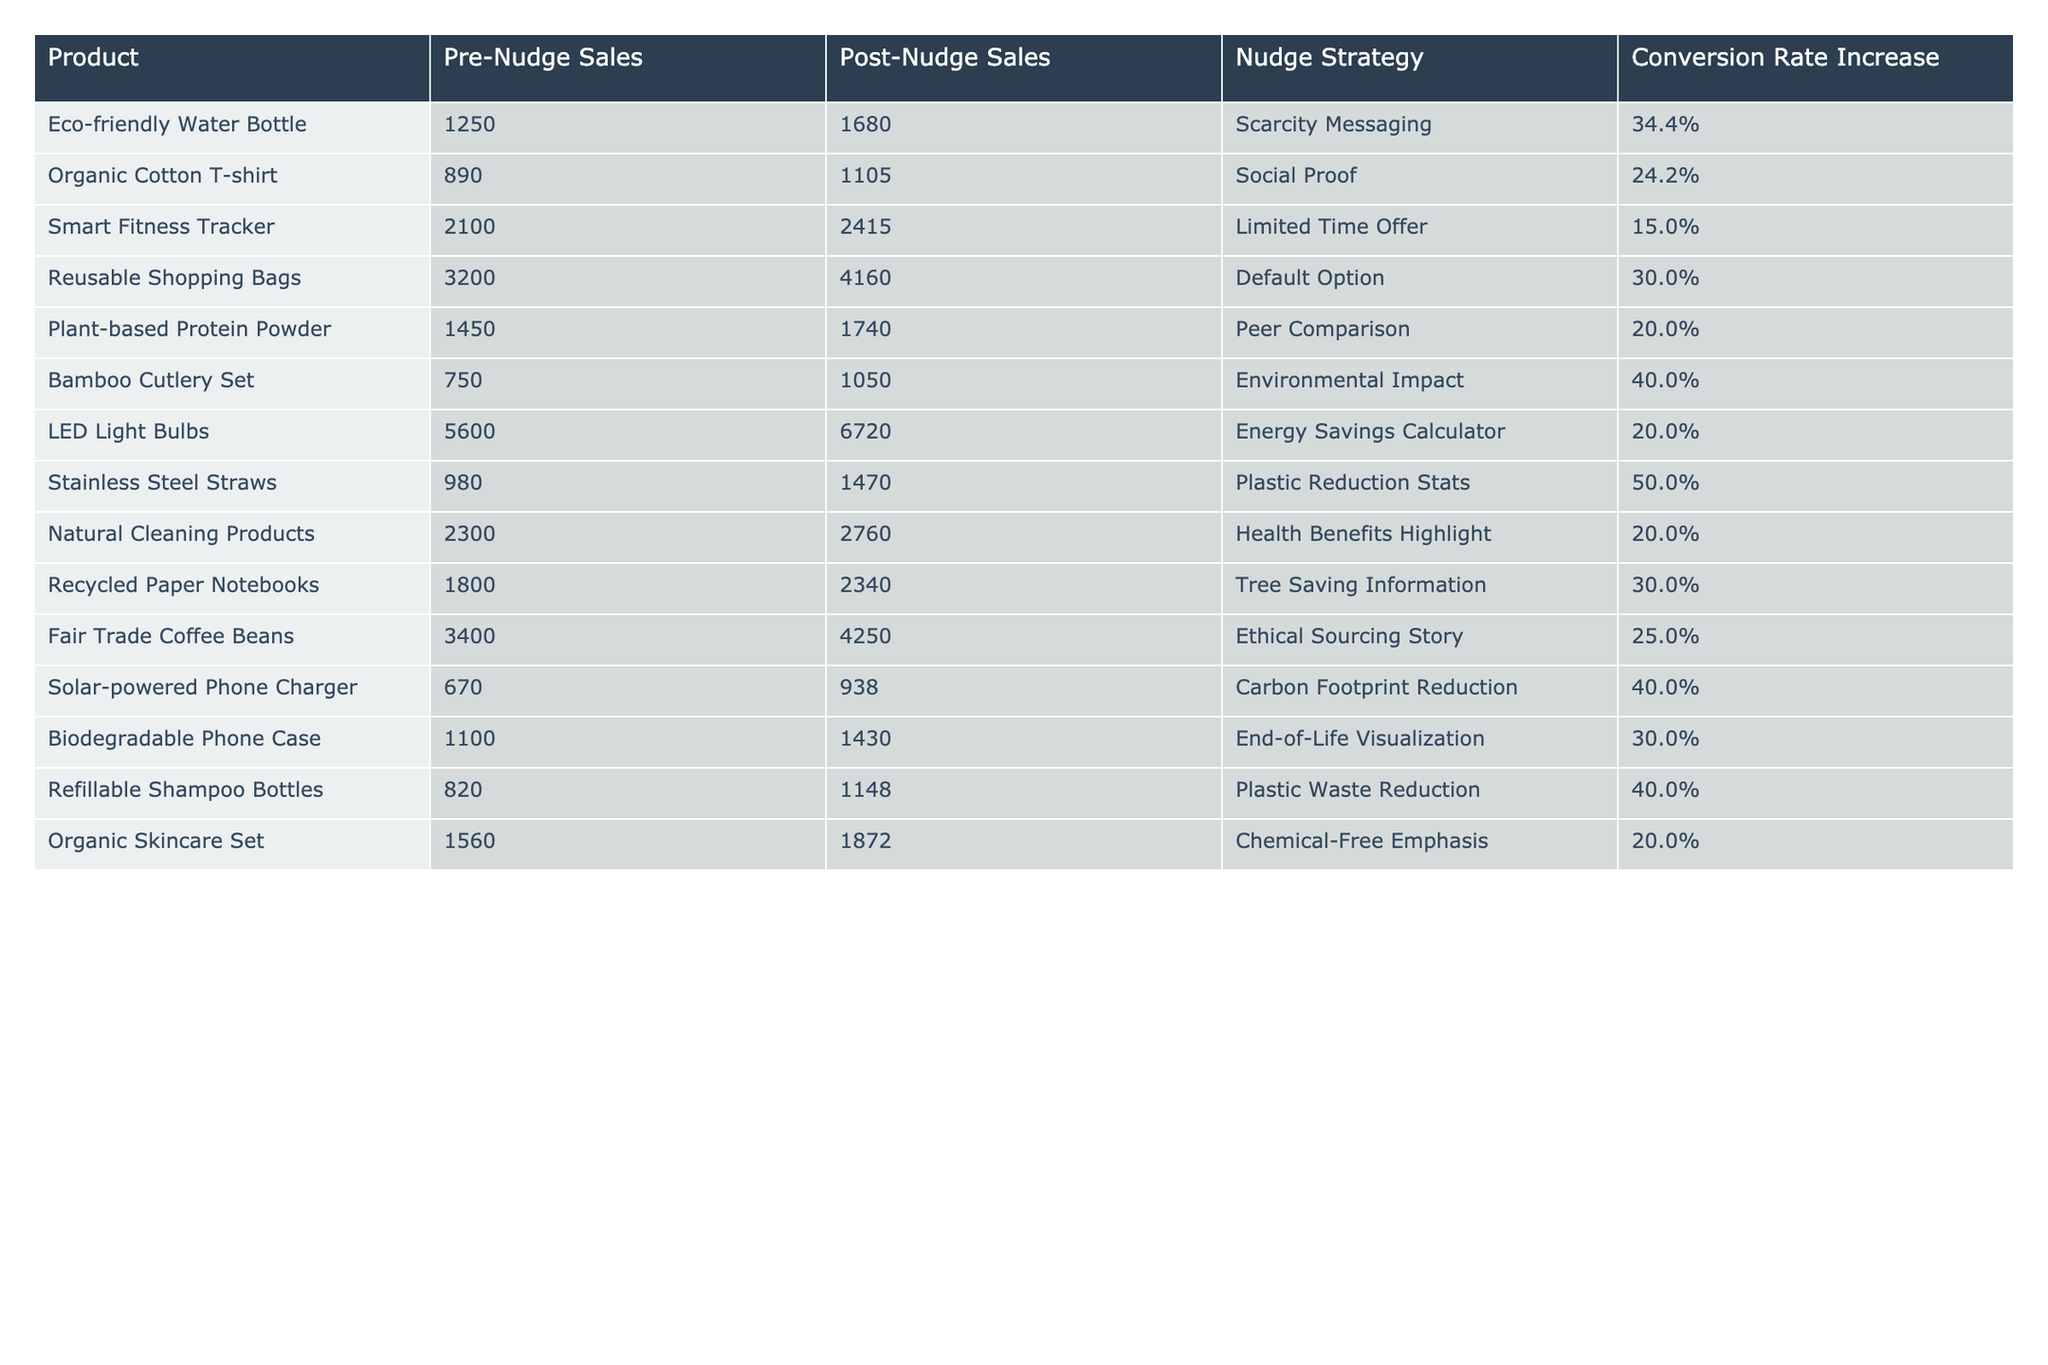What was the conversion rate increase for the Stainless Steel Straws? The table shows that the conversion rate increase for the Stainless Steel Straws is listed as 50.0%.
Answer: 50.0% Which product had the highest Pre-Nudge Sales? By looking at the Pre-Nudge Sales column, the highest sales recorded were for the LED Light Bulbs with 5600 units sold.
Answer: LED Light Bulbs How many more units of Refillable Shampoo Bottles were sold post-nudge compared to pre-nudge? To find the difference, we subtract Pre-Nudge Sales (820) from Post-Nudge Sales (1148): 1148 - 820 = 328 units.
Answer: 328 Did the Eco-friendly Water Bottle have a conversion rate increase below 35%? The table indicates that the conversion rate increase for the Eco-friendly Water Bottle is 34.4%, which is below 35%. Therefore, the answer is yes.
Answer: Yes What is the average conversion rate increase across all products listed? To get the average, we first sum the conversion rate increases: 34.4 + 24.2 + 15.0 + 30.0 + 20.0 + 40.0 + 20.0 + 50.0 + 20.0 + 30.0 + 25.0 + 40.0 + 30.0 + 20.0 =  455.0. Then divide by the total number of products (14): 455.0 / 14 ≈ 32.5%.
Answer: 32.5% Which nudge strategy proved to be the most effective in terms of conversion rate increase? The highest conversion rate increase is 50.0% for the Stainless Steel Straws, indicating that the Plastic Reduction Stats strategy was the most effective.
Answer: Plastic Reduction Stats What is the difference in sales for the Organic Cotton T-shirt before and after the nudge? The difference in sales can be calculated by subtracting Pre-Nudge Sales (890) from Post-Nudge Sales (1105): 1105 - 890 = 215 units.
Answer: 215 Which two products had a conversion rate increase of more than 40%? By examining the table, the products with more than 40% increase are the Stainless Steel Straws (50.0%) and the Bamboo Cutlery Set (40.0%).
Answer: Stainless Steel Straws, Bamboo Cutlery Set If we combine the post-nudge sales of the Eco-friendly Water Bottle and Reusable Shopping Bags, what is the total? To find this, we add the Post-Nudge Sales for both: Eco-friendly Water Bottle (1680) + Reusable Shopping Bags (4160) = 5840 total units sold.
Answer: 5840 Which product had the lowest Post-Nudge Sales? Looking at the Post-Nudge Sales column, the product with the lowest sales is the Solar-powered Phone Charger with 938 units sold.
Answer: Solar-powered Phone Charger Was the increase in Post-Nudge Sales for Organic Skincare Set greater than 300 units? The sales increased from 1560 to 1872, which is 1872 - 1560 = 312 units. Since 312 is greater than 300, the answer is yes.
Answer: Yes 